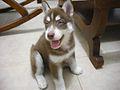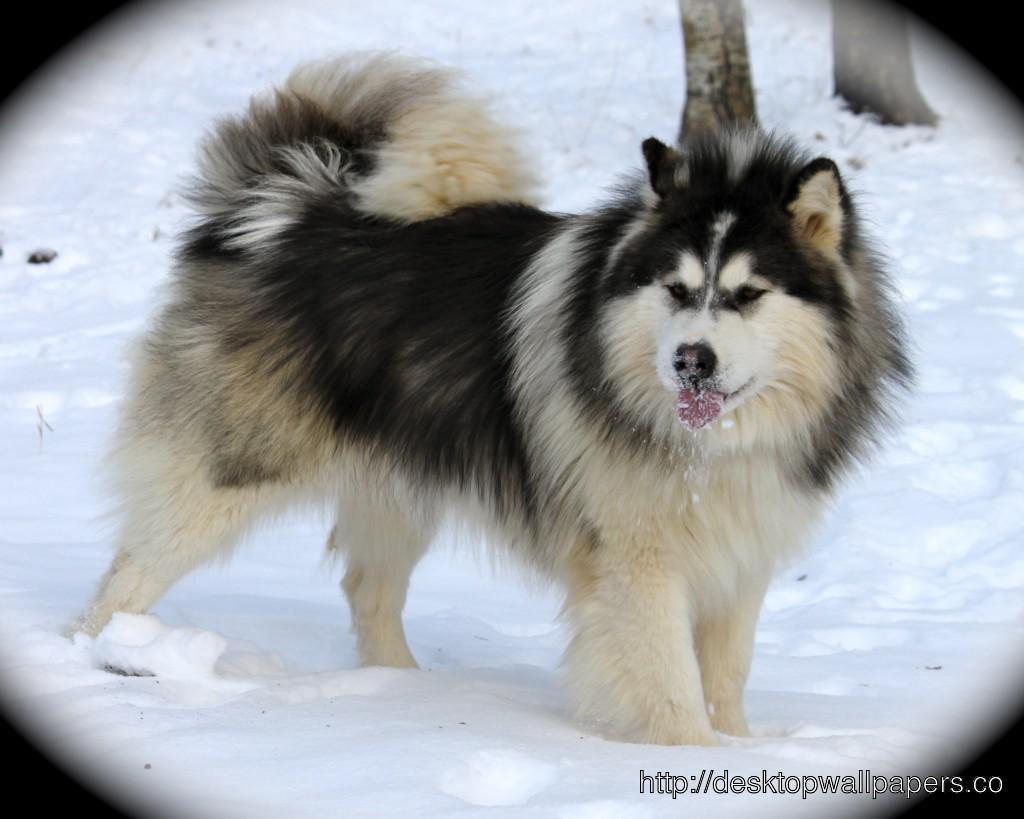The first image is the image on the left, the second image is the image on the right. Assess this claim about the two images: "The left image features a dog with an open mouth standing in profile in front of someone standing wearing pants.". Correct or not? Answer yes or no. No. 